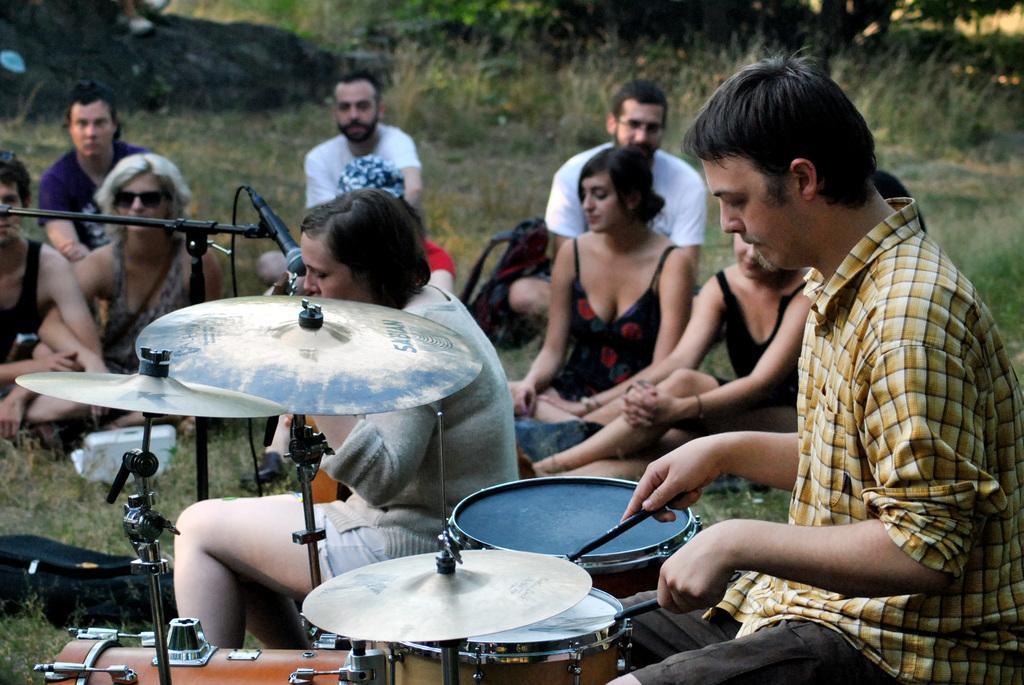Please provide a concise description of this image. In the image there is a man playing drum and a woman singing on mic,There are few people sat on grass looking at them. 